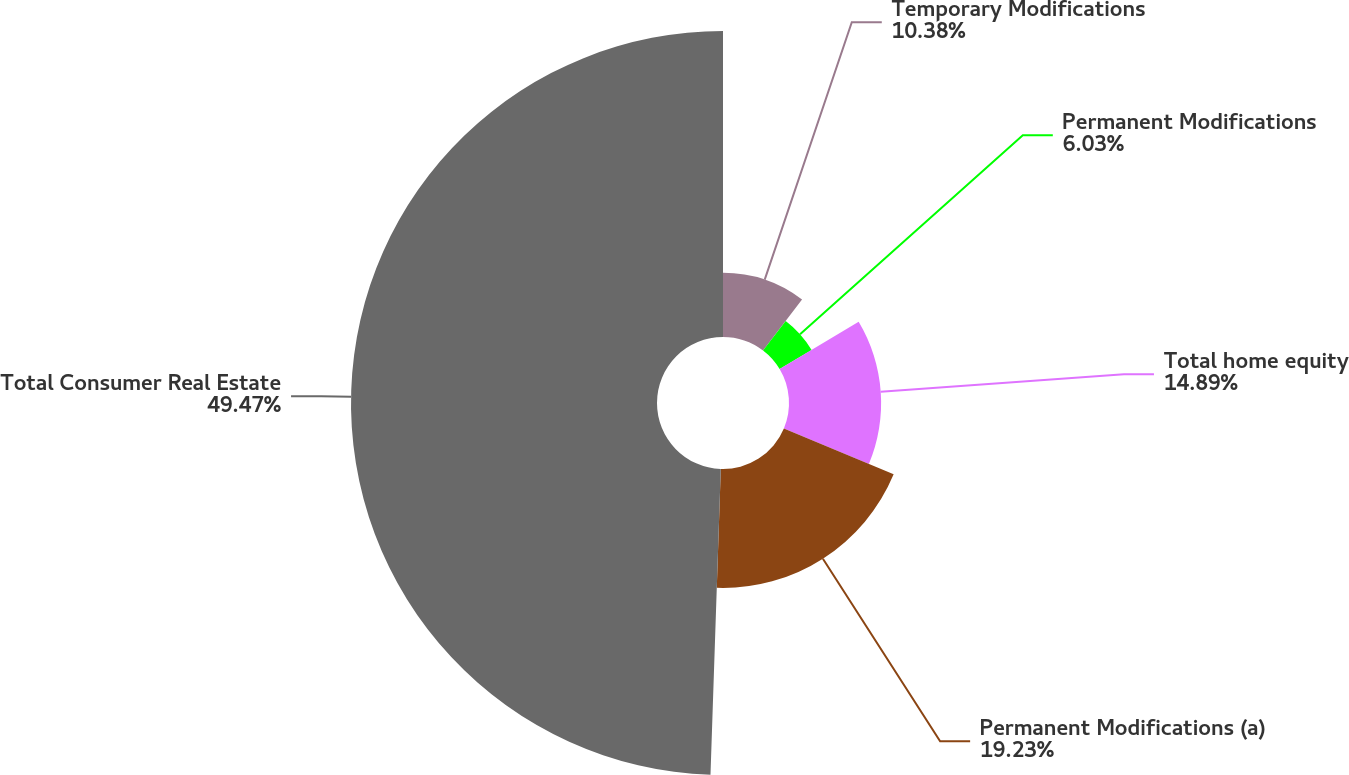<chart> <loc_0><loc_0><loc_500><loc_500><pie_chart><fcel>Temporary Modifications<fcel>Permanent Modifications<fcel>Total home equity<fcel>Permanent Modifications (a)<fcel>Total Consumer Real Estate<nl><fcel>10.38%<fcel>6.03%<fcel>14.89%<fcel>19.23%<fcel>49.46%<nl></chart> 